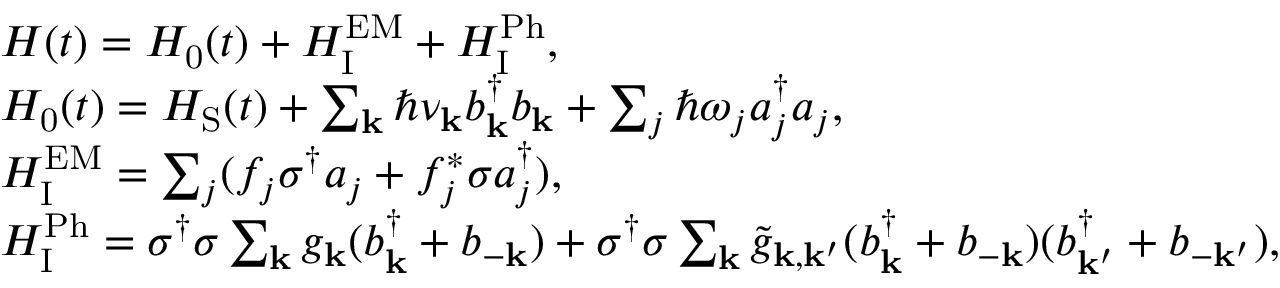<formula> <loc_0><loc_0><loc_500><loc_500>\begin{array} { r l } & { H ( t ) = H _ { 0 } ( t ) + H _ { I } ^ { E M } + H _ { I } ^ { P h } , } \\ & { H _ { 0 } ( t ) = H _ { S } ( t ) + \sum _ { k } \hbar { \nu } _ { k } b _ { k } ^ { \dagger } b _ { k } + \sum _ { j } \hbar { \omega } _ { j } a _ { j } ^ { \dagger } a _ { j } , } \\ & { H _ { I } ^ { E M } = \sum _ { j } ( f _ { j } \sigma ^ { \dagger } a _ { j } + f _ { j } ^ { \ast } \sigma a _ { j } ^ { \dagger } ) , } \\ & { H _ { I } ^ { P h } = \sigma ^ { \dagger } \sigma \sum _ { k } g _ { k } ( b _ { k } ^ { \dagger } + b _ { - k } ) + \sigma ^ { \dagger } \sigma \sum _ { k } \tilde { g } _ { k , k ^ { \prime } } ( b _ { k } ^ { \dagger } + b _ { - k } ) ( b _ { k ^ { \prime } } ^ { \dagger } + b _ { - k ^ { \prime } } ) , } \end{array}</formula> 